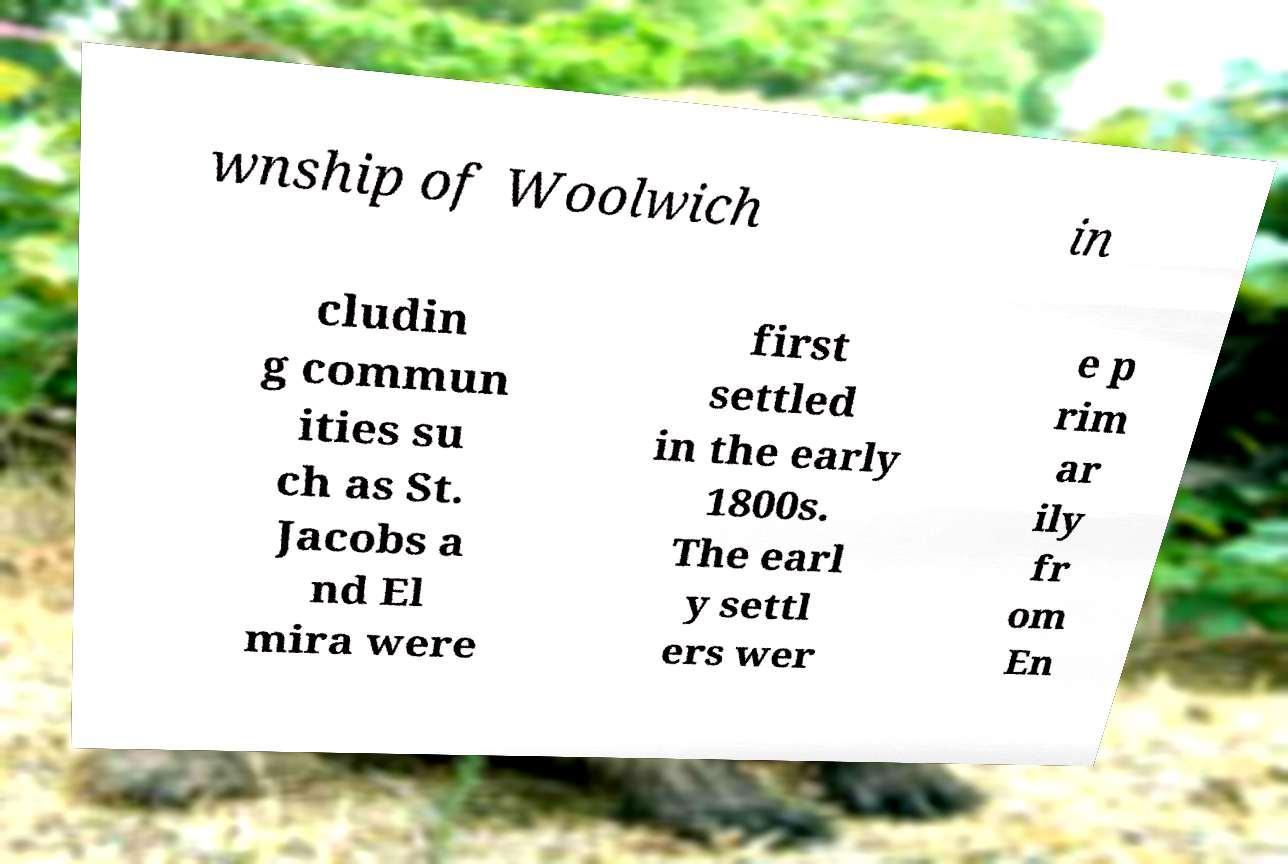Please read and relay the text visible in this image. What does it say? wnship of Woolwich in cludin g commun ities su ch as St. Jacobs a nd El mira were first settled in the early 1800s. The earl y settl ers wer e p rim ar ily fr om En 